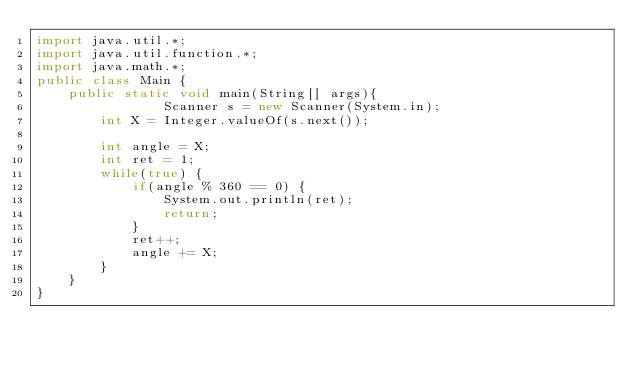Convert code to text. <code><loc_0><loc_0><loc_500><loc_500><_Java_>import java.util.*;
import java.util.function.*;
import java.math.*;
public class Main {
    public static void main(String[] args){
				Scanner s = new Scanner(System.in);
		int X = Integer.valueOf(s.next());
		
		int angle = X;
		int ret = 1;
		while(true) {
			if(angle % 360 == 0) {
				System.out.println(ret);
				return;
			}
			ret++;
			angle += X;
		}
	}
}</code> 